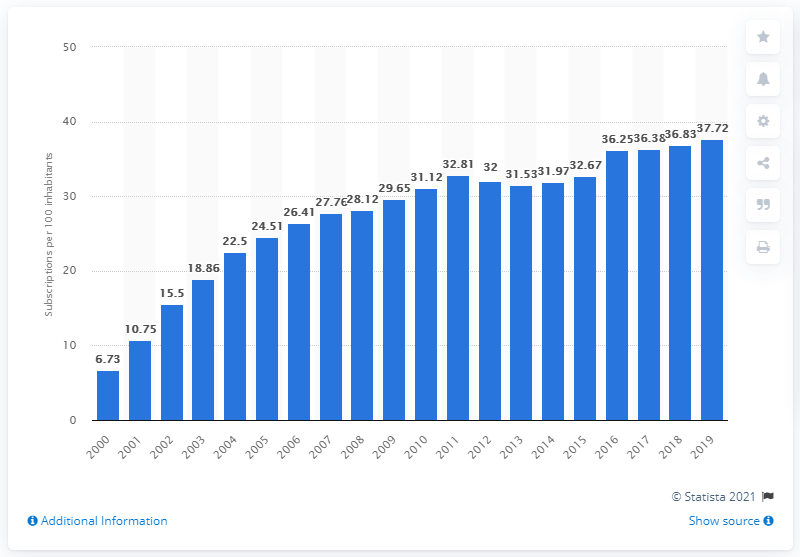Specify some key components in this picture. In 2019, there were 37.72 fixed broadband subscriptions for every 100 inhabitants in Hong Kong. 